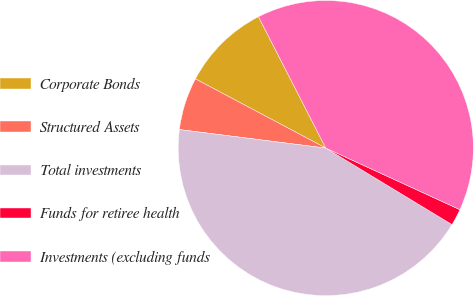Convert chart. <chart><loc_0><loc_0><loc_500><loc_500><pie_chart><fcel>Corporate Bonds<fcel>Structured Assets<fcel>Total investments<fcel>Funds for retiree health<fcel>Investments (excluding funds<nl><fcel>9.7%<fcel>5.76%<fcel>43.33%<fcel>1.82%<fcel>39.39%<nl></chart> 